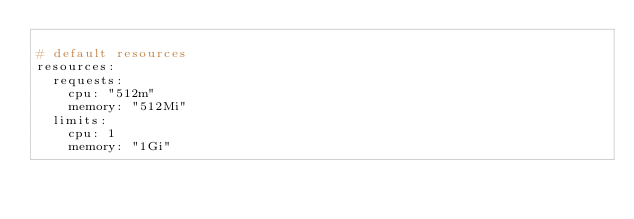Convert code to text. <code><loc_0><loc_0><loc_500><loc_500><_YAML_>
# default resources
resources:
  requests:
    cpu: "512m"
    memory: "512Mi"
  limits:
    cpu: 1
    memory: "1Gi"

</code> 